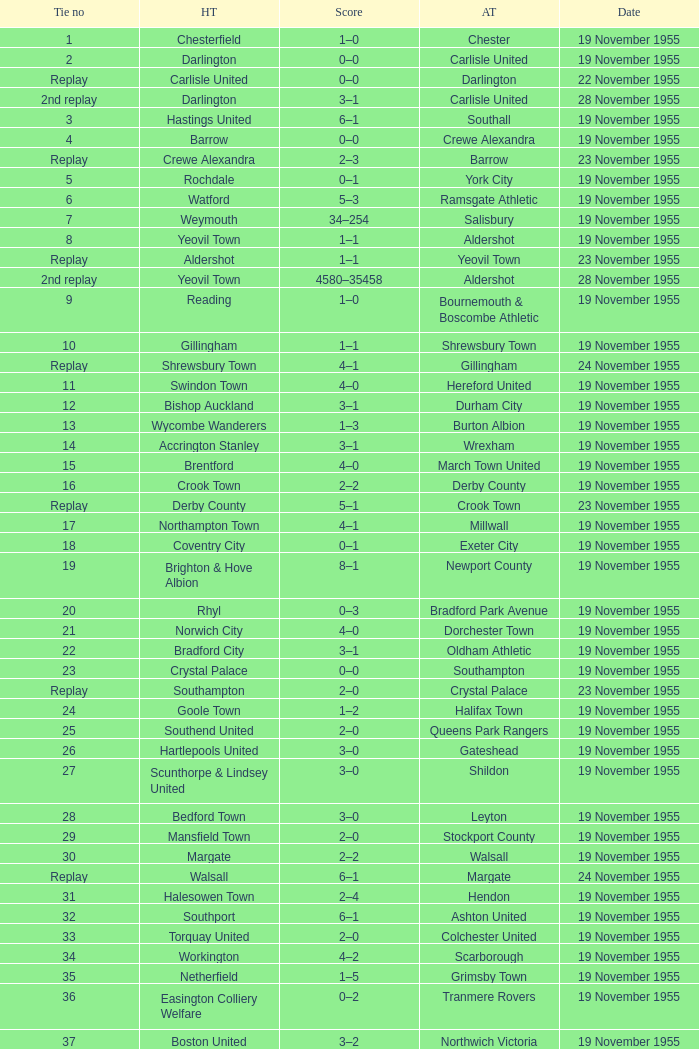What is the away team with a 5 tie no? York City. Can you give me this table as a dict? {'header': ['Tie no', 'HT', 'Score', 'AT', 'Date'], 'rows': [['1', 'Chesterfield', '1–0', 'Chester', '19 November 1955'], ['2', 'Darlington', '0–0', 'Carlisle United', '19 November 1955'], ['Replay', 'Carlisle United', '0–0', 'Darlington', '22 November 1955'], ['2nd replay', 'Darlington', '3–1', 'Carlisle United', '28 November 1955'], ['3', 'Hastings United', '6–1', 'Southall', '19 November 1955'], ['4', 'Barrow', '0–0', 'Crewe Alexandra', '19 November 1955'], ['Replay', 'Crewe Alexandra', '2–3', 'Barrow', '23 November 1955'], ['5', 'Rochdale', '0–1', 'York City', '19 November 1955'], ['6', 'Watford', '5–3', 'Ramsgate Athletic', '19 November 1955'], ['7', 'Weymouth', '34–254', 'Salisbury', '19 November 1955'], ['8', 'Yeovil Town', '1–1', 'Aldershot', '19 November 1955'], ['Replay', 'Aldershot', '1–1', 'Yeovil Town', '23 November 1955'], ['2nd replay', 'Yeovil Town', '4580–35458', 'Aldershot', '28 November 1955'], ['9', 'Reading', '1–0', 'Bournemouth & Boscombe Athletic', '19 November 1955'], ['10', 'Gillingham', '1–1', 'Shrewsbury Town', '19 November 1955'], ['Replay', 'Shrewsbury Town', '4–1', 'Gillingham', '24 November 1955'], ['11', 'Swindon Town', '4–0', 'Hereford United', '19 November 1955'], ['12', 'Bishop Auckland', '3–1', 'Durham City', '19 November 1955'], ['13', 'Wycombe Wanderers', '1–3', 'Burton Albion', '19 November 1955'], ['14', 'Accrington Stanley', '3–1', 'Wrexham', '19 November 1955'], ['15', 'Brentford', '4–0', 'March Town United', '19 November 1955'], ['16', 'Crook Town', '2–2', 'Derby County', '19 November 1955'], ['Replay', 'Derby County', '5–1', 'Crook Town', '23 November 1955'], ['17', 'Northampton Town', '4–1', 'Millwall', '19 November 1955'], ['18', 'Coventry City', '0–1', 'Exeter City', '19 November 1955'], ['19', 'Brighton & Hove Albion', '8–1', 'Newport County', '19 November 1955'], ['20', 'Rhyl', '0–3', 'Bradford Park Avenue', '19 November 1955'], ['21', 'Norwich City', '4–0', 'Dorchester Town', '19 November 1955'], ['22', 'Bradford City', '3–1', 'Oldham Athletic', '19 November 1955'], ['23', 'Crystal Palace', '0–0', 'Southampton', '19 November 1955'], ['Replay', 'Southampton', '2–0', 'Crystal Palace', '23 November 1955'], ['24', 'Goole Town', '1–2', 'Halifax Town', '19 November 1955'], ['25', 'Southend United', '2–0', 'Queens Park Rangers', '19 November 1955'], ['26', 'Hartlepools United', '3–0', 'Gateshead', '19 November 1955'], ['27', 'Scunthorpe & Lindsey United', '3–0', 'Shildon', '19 November 1955'], ['28', 'Bedford Town', '3–0', 'Leyton', '19 November 1955'], ['29', 'Mansfield Town', '2–0', 'Stockport County', '19 November 1955'], ['30', 'Margate', '2–2', 'Walsall', '19 November 1955'], ['Replay', 'Walsall', '6–1', 'Margate', '24 November 1955'], ['31', 'Halesowen Town', '2–4', 'Hendon', '19 November 1955'], ['32', 'Southport', '6–1', 'Ashton United', '19 November 1955'], ['33', 'Torquay United', '2–0', 'Colchester United', '19 November 1955'], ['34', 'Workington', '4–2', 'Scarborough', '19 November 1955'], ['35', 'Netherfield', '1–5', 'Grimsby Town', '19 November 1955'], ['36', 'Easington Colliery Welfare', '0–2', 'Tranmere Rovers', '19 November 1955'], ['37', 'Boston United', '3–2', 'Northwich Victoria', '19 November 1955'], ['38', 'Peterborough United', '3–1', 'Ipswich Town', '19 November 1955'], ['39', 'Leyton Orient', '7–1', 'Lovells Athletic', '19 November 1955'], ['40', 'Skegness Town', '0–4', 'Worksop Town', '19 November 1955']]} 